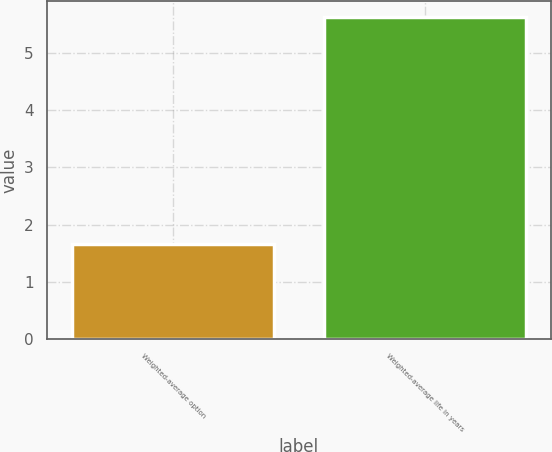Convert chart to OTSL. <chart><loc_0><loc_0><loc_500><loc_500><bar_chart><fcel>Weighted-average option<fcel>Weighted-average life in years<nl><fcel>1.67<fcel>5.62<nl></chart> 